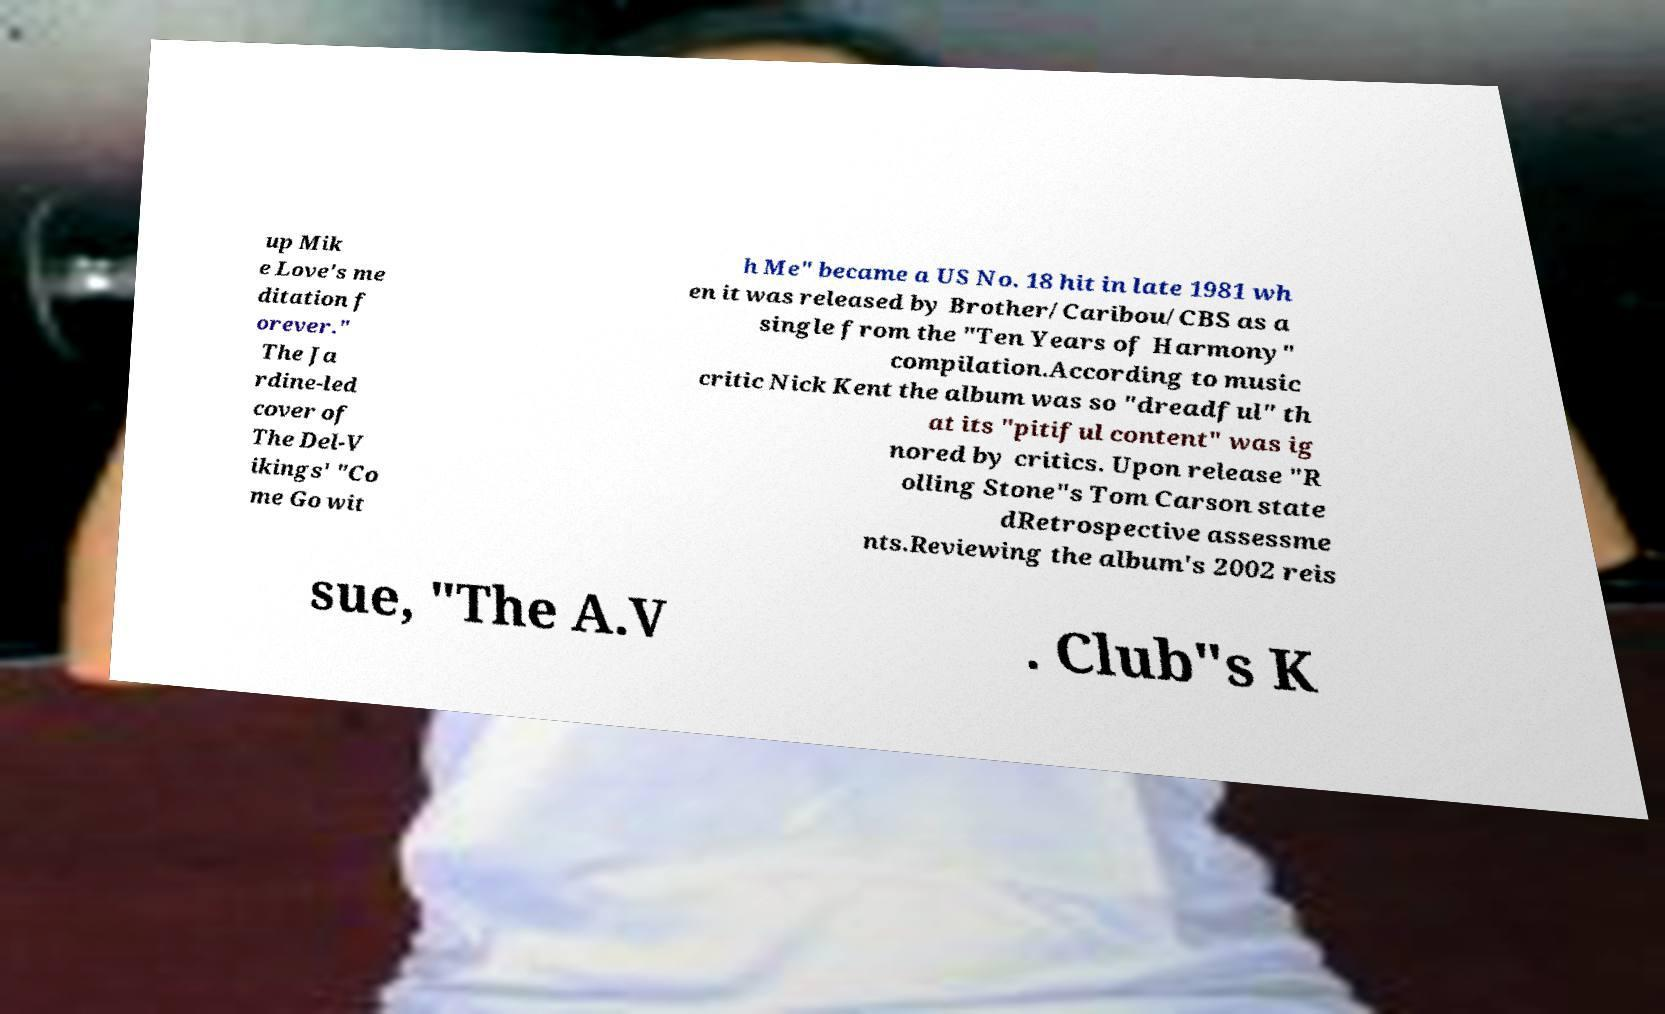Can you read and provide the text displayed in the image?This photo seems to have some interesting text. Can you extract and type it out for me? up Mik e Love's me ditation f orever." The Ja rdine-led cover of The Del-V ikings' "Co me Go wit h Me" became a US No. 18 hit in late 1981 wh en it was released by Brother/Caribou/CBS as a single from the "Ten Years of Harmony" compilation.According to music critic Nick Kent the album was so "dreadful" th at its "pitiful content" was ig nored by critics. Upon release "R olling Stone"s Tom Carson state dRetrospective assessme nts.Reviewing the album's 2002 reis sue, "The A.V . Club"s K 